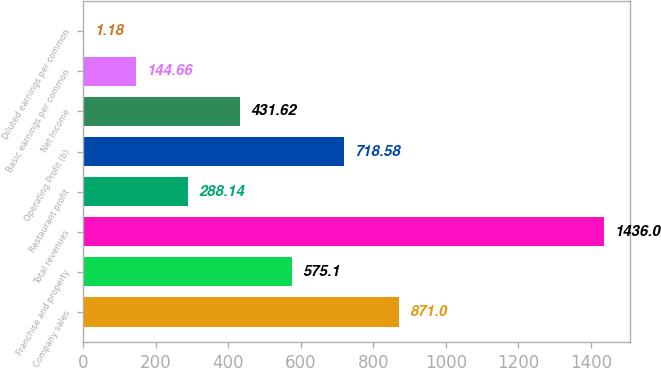Convert chart to OTSL. <chart><loc_0><loc_0><loc_500><loc_500><bar_chart><fcel>Company sales<fcel>Franchise and property<fcel>Total revenues<fcel>Restaurant profit<fcel>Operating Profit (b)<fcel>Net Income<fcel>Basic earnings per common<fcel>Diluted earnings per common<nl><fcel>871<fcel>575.1<fcel>1436<fcel>288.14<fcel>718.58<fcel>431.62<fcel>144.66<fcel>1.18<nl></chart> 